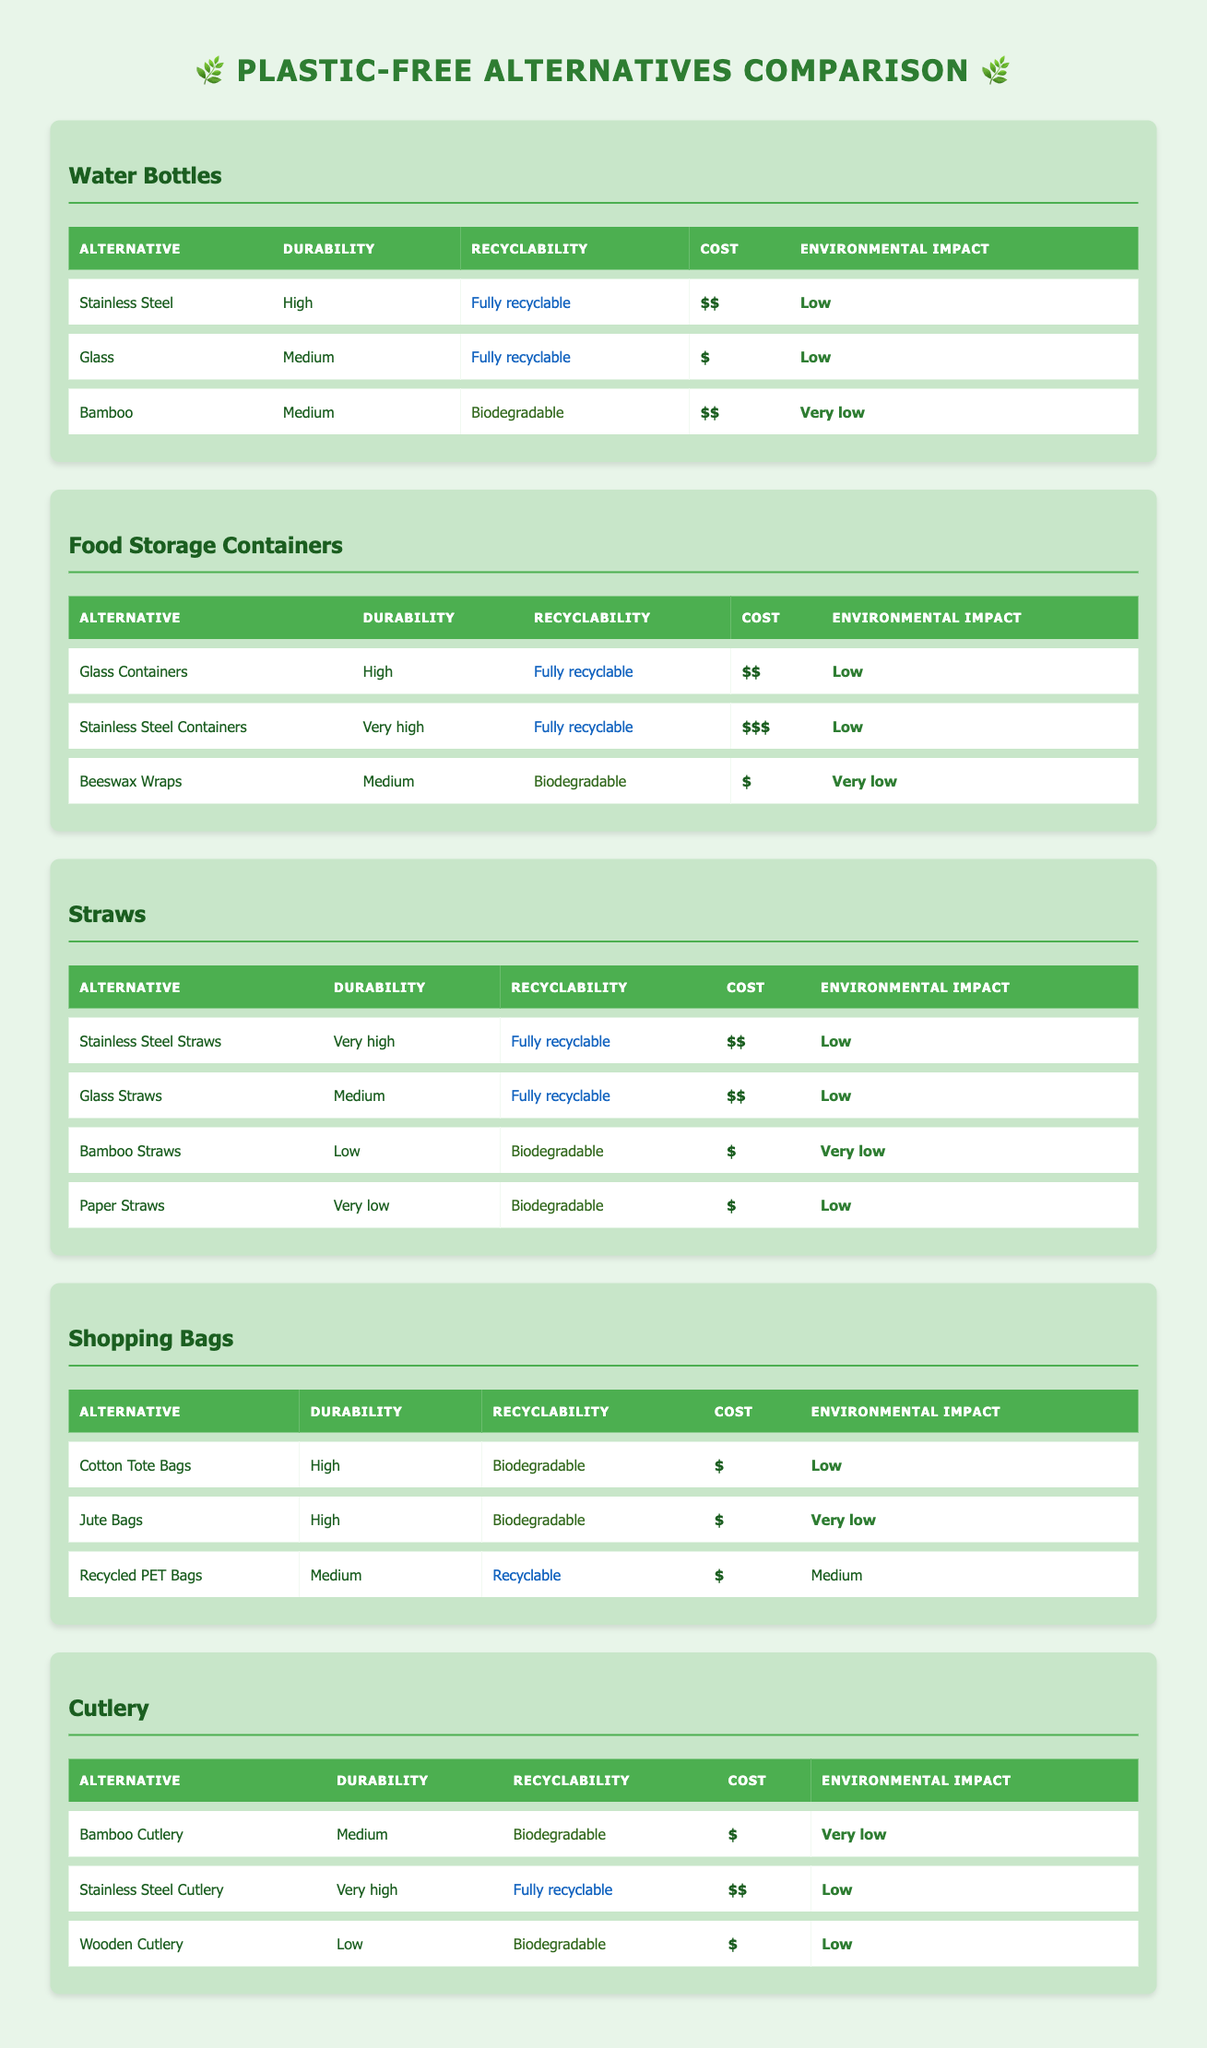What is the durability level of Glass food storage containers? The durability level is listed in the table under the "Durability" column for Glass Containers. The value for Glass Containers is "High."
Answer: High How many alternatives for shopping bags have a very low environmental impact? By examining the "Environmental Impact" column for the Shopping Bags category, we see that there are two options with "Very low" impact: Jute Bags and Cotton Tote Bags. Therefore, there are 2 alternatives.
Answer: 2 Which alternative has the highest durability in the Cutlery category? Looking at the "Durability" column in the Cutlery category, the highest durability is "Very high," which is found for Stainless Steel Cutlery.
Answer: Stainless Steel Cutlery Is Beeswax Wraps recyclable? In the Food Storage Containers category, Beeswax Wraps are marked under the "Recyclability" column as "Biodegradable." Therefore, they are not recyclable.
Answer: No Which water bottle alternative has a lower cost: Bamboo or Glass? The cost of Bamboo is listed as "$$" while the cost for Glass is listed as "$." Since "$" is lower than "$$", Glass is the alternative with a lower cost.
Answer: Glass How does the environmental impact of Stainless Steel Straws compare to Bamboo Straws? In the "Environmental Impact" column, Stainless Steel Straws are listed as having a "Low" impact, while Bamboo Straws are noted as having a "Very low" impact. Comparatively, "Very low" is better than "Low," meaning Bamboo Straws are more environmentally friendly.
Answer: Bamboo Straws What is the recyclability status of Recycled PET Bags in the Shopping Bags category? Recycled PET Bags in the Shopping Bags category are labeled as "Recyclable" under the "Recyclability" column.
Answer: Recyclable What is the average cost of the alternatives for Food Storage Containers? The costs are "$$", "$$$", and "$" for Glass Containers, Stainless Steel Containers, and Beeswax Wraps, respectively. To find the average: (2 + 3 + 1) / 3 = 2. The average cost rating is "$$."
Answer: $$ How many alternatives in the Straws category are fully recyclable? In the Straws category, Stainless Steel Straws, Glass Straws, and Paper Straws have their recyclability status; Stainless Steel and Glass are "Fully recyclable." Therefore, there are 2 fully recyclable alternatives.
Answer: 2 